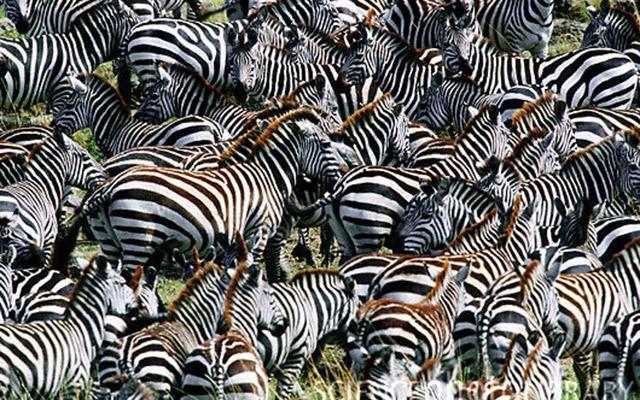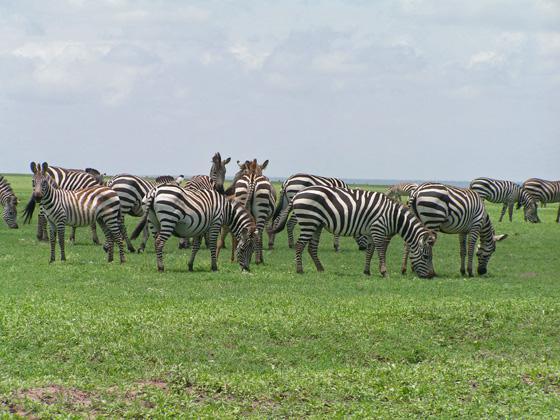The first image is the image on the left, the second image is the image on the right. Given the left and right images, does the statement "At least one image shows a row of zebras in similar poses in terms of the way their bodies are turned and their eyes are gazing." hold true? Answer yes or no. No. The first image is the image on the left, the second image is the image on the right. For the images displayed, is the sentence "Some zebras are eating grass." factually correct? Answer yes or no. Yes. 